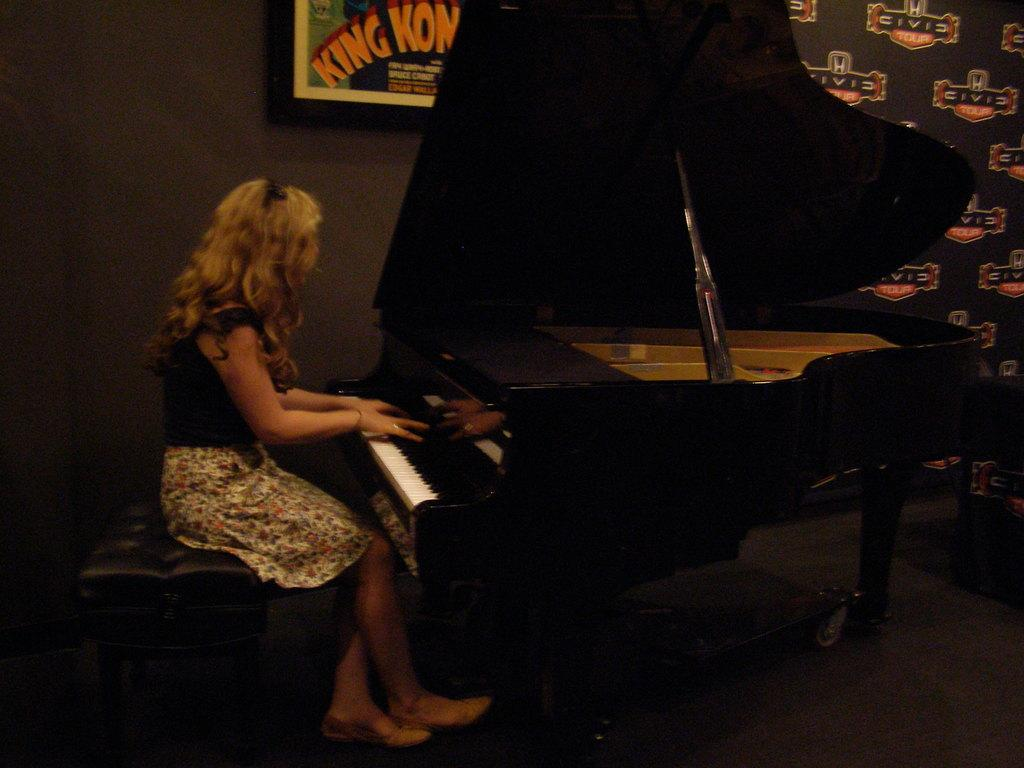What is the person in the image doing? The person is sitting in front of a piano. Can you describe the background of the image? There is a board on the wall in the background. What type of pollution can be seen in the image? There is no pollution visible in the image. How many hands does the laborer have in the image? There is no laborer present in the image. 